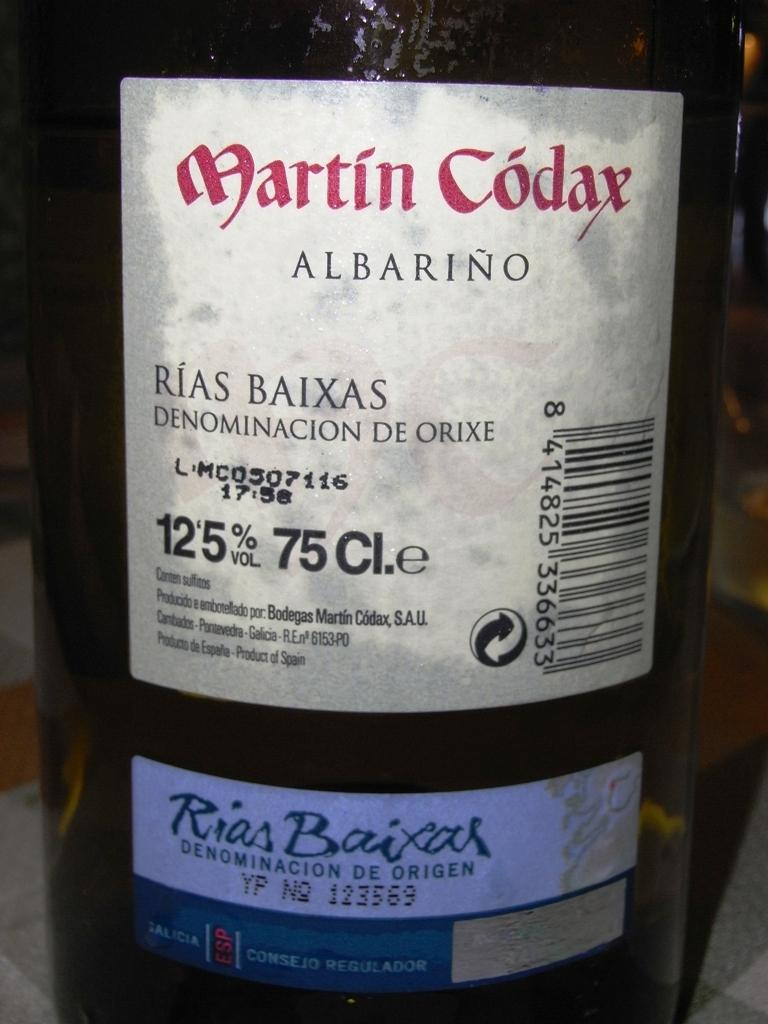<image>
Present a compact description of the photo's key features. A large bottle labeled Martin Codax Albarino 12.5% 